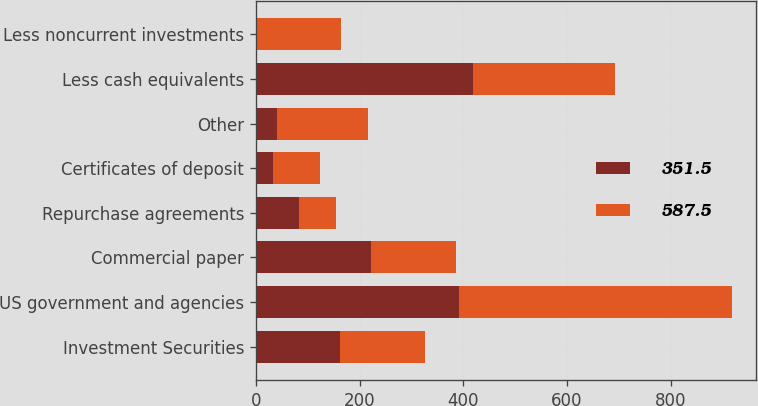Convert chart. <chart><loc_0><loc_0><loc_500><loc_500><stacked_bar_chart><ecel><fcel>Investment Securities<fcel>US government and agencies<fcel>Commercial paper<fcel>Repurchase agreements<fcel>Certificates of deposit<fcel>Other<fcel>Less cash equivalents<fcel>Less noncurrent investments<nl><fcel>351.5<fcel>162.85<fcel>391.1<fcel>222.1<fcel>83.8<fcel>33.6<fcel>41.2<fcel>418<fcel>2.3<nl><fcel>587.5<fcel>162.85<fcel>527<fcel>163.2<fcel>70<fcel>90.1<fcel>175.4<fcel>275.7<fcel>162.5<nl></chart> 